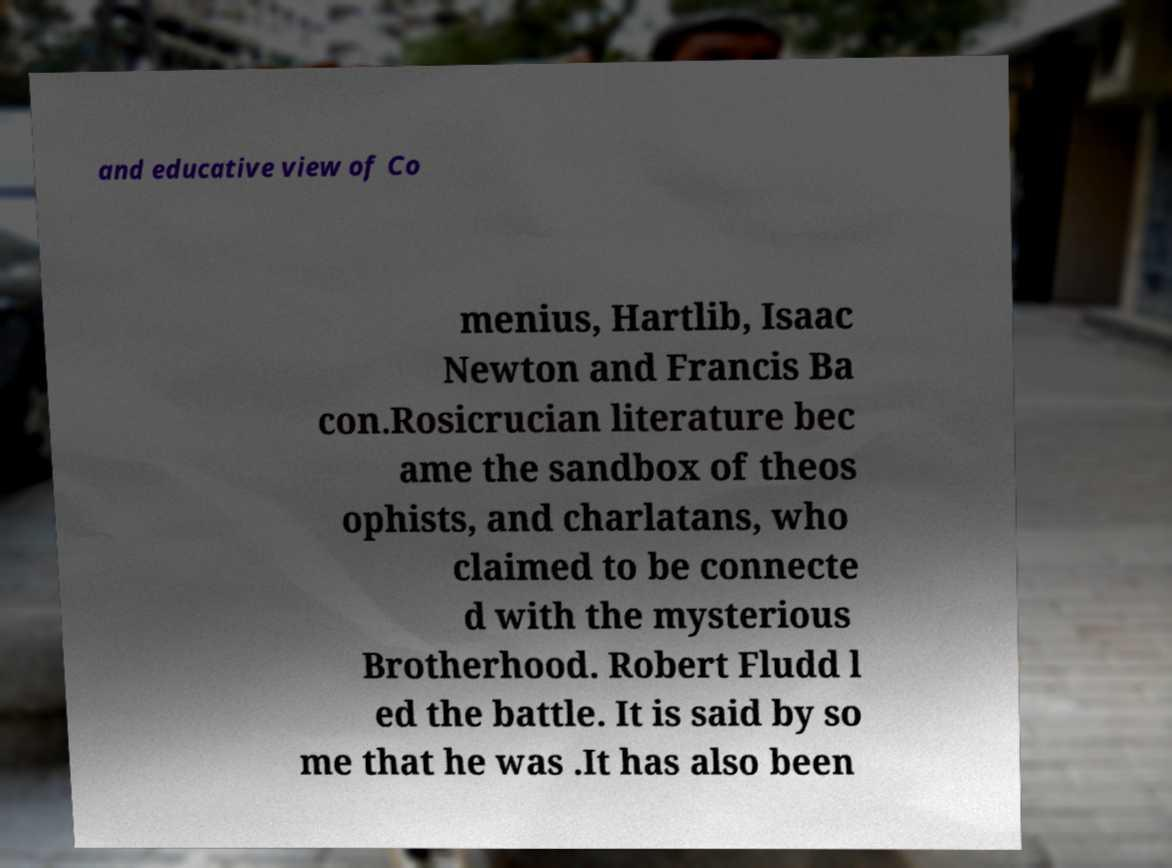Could you assist in decoding the text presented in this image and type it out clearly? and educative view of Co menius, Hartlib, Isaac Newton and Francis Ba con.Rosicrucian literature bec ame the sandbox of theos ophists, and charlatans, who claimed to be connecte d with the mysterious Brotherhood. Robert Fludd l ed the battle. It is said by so me that he was .It has also been 